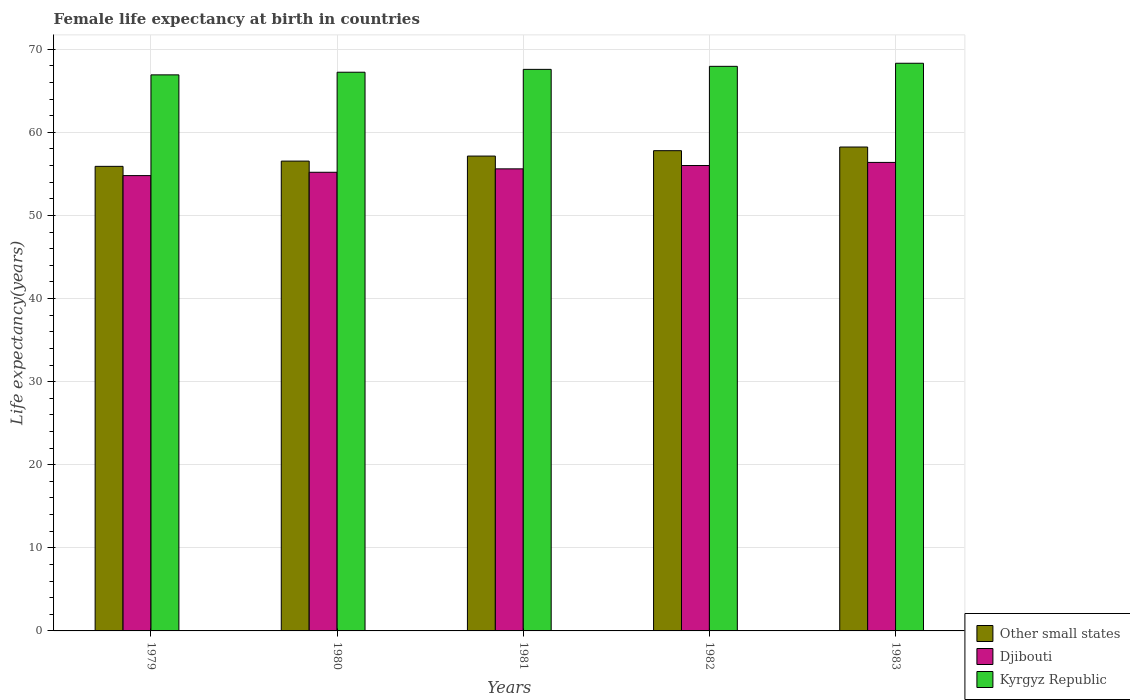How many groups of bars are there?
Your response must be concise. 5. Are the number of bars per tick equal to the number of legend labels?
Ensure brevity in your answer.  Yes. How many bars are there on the 4th tick from the right?
Make the answer very short. 3. What is the female life expectancy at birth in Other small states in 1979?
Your answer should be very brief. 55.91. Across all years, what is the maximum female life expectancy at birth in Other small states?
Your answer should be very brief. 58.24. Across all years, what is the minimum female life expectancy at birth in Djibouti?
Your answer should be very brief. 54.8. In which year was the female life expectancy at birth in Kyrgyz Republic maximum?
Make the answer very short. 1983. In which year was the female life expectancy at birth in Djibouti minimum?
Make the answer very short. 1979. What is the total female life expectancy at birth in Kyrgyz Republic in the graph?
Ensure brevity in your answer.  338.01. What is the difference between the female life expectancy at birth in Other small states in 1979 and that in 1980?
Make the answer very short. -0.63. What is the difference between the female life expectancy at birth in Djibouti in 1982 and the female life expectancy at birth in Kyrgyz Republic in 1983?
Make the answer very short. -12.31. What is the average female life expectancy at birth in Other small states per year?
Offer a very short reply. 57.13. In the year 1980, what is the difference between the female life expectancy at birth in Djibouti and female life expectancy at birth in Other small states?
Give a very brief answer. -1.34. What is the ratio of the female life expectancy at birth in Djibouti in 1982 to that in 1983?
Provide a short and direct response. 0.99. Is the female life expectancy at birth in Kyrgyz Republic in 1979 less than that in 1982?
Offer a terse response. Yes. Is the difference between the female life expectancy at birth in Djibouti in 1980 and 1983 greater than the difference between the female life expectancy at birth in Other small states in 1980 and 1983?
Your answer should be compact. Yes. What is the difference between the highest and the second highest female life expectancy at birth in Djibouti?
Provide a succinct answer. 0.38. What is the difference between the highest and the lowest female life expectancy at birth in Kyrgyz Republic?
Offer a terse response. 1.4. What does the 2nd bar from the left in 1982 represents?
Provide a short and direct response. Djibouti. What does the 3rd bar from the right in 1979 represents?
Your answer should be compact. Other small states. Is it the case that in every year, the sum of the female life expectancy at birth in Other small states and female life expectancy at birth in Djibouti is greater than the female life expectancy at birth in Kyrgyz Republic?
Make the answer very short. Yes. Are all the bars in the graph horizontal?
Give a very brief answer. No. How many years are there in the graph?
Keep it short and to the point. 5. Does the graph contain any zero values?
Provide a short and direct response. No. Does the graph contain grids?
Ensure brevity in your answer.  Yes. Where does the legend appear in the graph?
Provide a short and direct response. Bottom right. What is the title of the graph?
Provide a short and direct response. Female life expectancy at birth in countries. What is the label or title of the X-axis?
Provide a succinct answer. Years. What is the label or title of the Y-axis?
Your answer should be very brief. Life expectancy(years). What is the Life expectancy(years) of Other small states in 1979?
Give a very brief answer. 55.91. What is the Life expectancy(years) of Djibouti in 1979?
Make the answer very short. 54.8. What is the Life expectancy(years) in Kyrgyz Republic in 1979?
Give a very brief answer. 66.92. What is the Life expectancy(years) of Other small states in 1980?
Ensure brevity in your answer.  56.54. What is the Life expectancy(years) of Djibouti in 1980?
Keep it short and to the point. 55.2. What is the Life expectancy(years) of Kyrgyz Republic in 1980?
Keep it short and to the point. 67.24. What is the Life expectancy(years) in Other small states in 1981?
Provide a short and direct response. 57.15. What is the Life expectancy(years) in Djibouti in 1981?
Ensure brevity in your answer.  55.61. What is the Life expectancy(years) of Kyrgyz Republic in 1981?
Provide a short and direct response. 67.58. What is the Life expectancy(years) in Other small states in 1982?
Your answer should be compact. 57.8. What is the Life expectancy(years) in Djibouti in 1982?
Your response must be concise. 56.01. What is the Life expectancy(years) in Kyrgyz Republic in 1982?
Give a very brief answer. 67.95. What is the Life expectancy(years) of Other small states in 1983?
Make the answer very short. 58.24. What is the Life expectancy(years) of Djibouti in 1983?
Your answer should be very brief. 56.39. What is the Life expectancy(years) of Kyrgyz Republic in 1983?
Give a very brief answer. 68.32. Across all years, what is the maximum Life expectancy(years) in Other small states?
Your response must be concise. 58.24. Across all years, what is the maximum Life expectancy(years) in Djibouti?
Give a very brief answer. 56.39. Across all years, what is the maximum Life expectancy(years) in Kyrgyz Republic?
Give a very brief answer. 68.32. Across all years, what is the minimum Life expectancy(years) of Other small states?
Offer a terse response. 55.91. Across all years, what is the minimum Life expectancy(years) in Djibouti?
Give a very brief answer. 54.8. Across all years, what is the minimum Life expectancy(years) in Kyrgyz Republic?
Ensure brevity in your answer.  66.92. What is the total Life expectancy(years) of Other small states in the graph?
Your answer should be very brief. 285.64. What is the total Life expectancy(years) of Djibouti in the graph?
Your answer should be very brief. 278. What is the total Life expectancy(years) in Kyrgyz Republic in the graph?
Provide a short and direct response. 338.01. What is the difference between the Life expectancy(years) of Other small states in 1979 and that in 1980?
Keep it short and to the point. -0.63. What is the difference between the Life expectancy(years) of Djibouti in 1979 and that in 1980?
Ensure brevity in your answer.  -0.4. What is the difference between the Life expectancy(years) of Kyrgyz Republic in 1979 and that in 1980?
Provide a succinct answer. -0.32. What is the difference between the Life expectancy(years) of Other small states in 1979 and that in 1981?
Your answer should be very brief. -1.24. What is the difference between the Life expectancy(years) in Djibouti in 1979 and that in 1981?
Offer a very short reply. -0.81. What is the difference between the Life expectancy(years) of Kyrgyz Republic in 1979 and that in 1981?
Your answer should be compact. -0.66. What is the difference between the Life expectancy(years) of Other small states in 1979 and that in 1982?
Ensure brevity in your answer.  -1.89. What is the difference between the Life expectancy(years) of Djibouti in 1979 and that in 1982?
Ensure brevity in your answer.  -1.21. What is the difference between the Life expectancy(years) in Kyrgyz Republic in 1979 and that in 1982?
Keep it short and to the point. -1.03. What is the difference between the Life expectancy(years) of Other small states in 1979 and that in 1983?
Your response must be concise. -2.33. What is the difference between the Life expectancy(years) of Djibouti in 1979 and that in 1983?
Provide a succinct answer. -1.59. What is the difference between the Life expectancy(years) in Kyrgyz Republic in 1979 and that in 1983?
Provide a short and direct response. -1.4. What is the difference between the Life expectancy(years) of Other small states in 1980 and that in 1981?
Offer a terse response. -0.61. What is the difference between the Life expectancy(years) of Djibouti in 1980 and that in 1981?
Your answer should be compact. -0.41. What is the difference between the Life expectancy(years) of Kyrgyz Republic in 1980 and that in 1981?
Keep it short and to the point. -0.34. What is the difference between the Life expectancy(years) in Other small states in 1980 and that in 1982?
Your answer should be very brief. -1.25. What is the difference between the Life expectancy(years) of Djibouti in 1980 and that in 1982?
Offer a very short reply. -0.81. What is the difference between the Life expectancy(years) of Kyrgyz Republic in 1980 and that in 1982?
Provide a short and direct response. -0.71. What is the difference between the Life expectancy(years) in Other small states in 1980 and that in 1983?
Your response must be concise. -1.69. What is the difference between the Life expectancy(years) in Djibouti in 1980 and that in 1983?
Your response must be concise. -1.19. What is the difference between the Life expectancy(years) in Kyrgyz Republic in 1980 and that in 1983?
Your response must be concise. -1.08. What is the difference between the Life expectancy(years) in Other small states in 1981 and that in 1982?
Keep it short and to the point. -0.65. What is the difference between the Life expectancy(years) of Djibouti in 1981 and that in 1982?
Provide a short and direct response. -0.4. What is the difference between the Life expectancy(years) in Kyrgyz Republic in 1981 and that in 1982?
Offer a terse response. -0.36. What is the difference between the Life expectancy(years) in Other small states in 1981 and that in 1983?
Keep it short and to the point. -1.09. What is the difference between the Life expectancy(years) in Djibouti in 1981 and that in 1983?
Give a very brief answer. -0.78. What is the difference between the Life expectancy(years) of Kyrgyz Republic in 1981 and that in 1983?
Offer a very short reply. -0.73. What is the difference between the Life expectancy(years) of Other small states in 1982 and that in 1983?
Your response must be concise. -0.44. What is the difference between the Life expectancy(years) in Djibouti in 1982 and that in 1983?
Provide a succinct answer. -0.38. What is the difference between the Life expectancy(years) in Kyrgyz Republic in 1982 and that in 1983?
Make the answer very short. -0.37. What is the difference between the Life expectancy(years) in Other small states in 1979 and the Life expectancy(years) in Djibouti in 1980?
Ensure brevity in your answer.  0.71. What is the difference between the Life expectancy(years) of Other small states in 1979 and the Life expectancy(years) of Kyrgyz Republic in 1980?
Keep it short and to the point. -11.33. What is the difference between the Life expectancy(years) of Djibouti in 1979 and the Life expectancy(years) of Kyrgyz Republic in 1980?
Your answer should be very brief. -12.44. What is the difference between the Life expectancy(years) in Other small states in 1979 and the Life expectancy(years) in Djibouti in 1981?
Your answer should be compact. 0.3. What is the difference between the Life expectancy(years) of Other small states in 1979 and the Life expectancy(years) of Kyrgyz Republic in 1981?
Make the answer very short. -11.67. What is the difference between the Life expectancy(years) of Djibouti in 1979 and the Life expectancy(years) of Kyrgyz Republic in 1981?
Offer a terse response. -12.79. What is the difference between the Life expectancy(years) in Other small states in 1979 and the Life expectancy(years) in Djibouti in 1982?
Ensure brevity in your answer.  -0.1. What is the difference between the Life expectancy(years) in Other small states in 1979 and the Life expectancy(years) in Kyrgyz Republic in 1982?
Keep it short and to the point. -12.04. What is the difference between the Life expectancy(years) in Djibouti in 1979 and the Life expectancy(years) in Kyrgyz Republic in 1982?
Your response must be concise. -13.15. What is the difference between the Life expectancy(years) of Other small states in 1979 and the Life expectancy(years) of Djibouti in 1983?
Make the answer very short. -0.47. What is the difference between the Life expectancy(years) in Other small states in 1979 and the Life expectancy(years) in Kyrgyz Republic in 1983?
Make the answer very short. -12.41. What is the difference between the Life expectancy(years) of Djibouti in 1979 and the Life expectancy(years) of Kyrgyz Republic in 1983?
Your response must be concise. -13.52. What is the difference between the Life expectancy(years) of Other small states in 1980 and the Life expectancy(years) of Djibouti in 1981?
Provide a succinct answer. 0.93. What is the difference between the Life expectancy(years) in Other small states in 1980 and the Life expectancy(years) in Kyrgyz Republic in 1981?
Offer a terse response. -11.04. What is the difference between the Life expectancy(years) in Djibouti in 1980 and the Life expectancy(years) in Kyrgyz Republic in 1981?
Provide a succinct answer. -12.38. What is the difference between the Life expectancy(years) of Other small states in 1980 and the Life expectancy(years) of Djibouti in 1982?
Provide a short and direct response. 0.53. What is the difference between the Life expectancy(years) in Other small states in 1980 and the Life expectancy(years) in Kyrgyz Republic in 1982?
Your answer should be compact. -11.4. What is the difference between the Life expectancy(years) of Djibouti in 1980 and the Life expectancy(years) of Kyrgyz Republic in 1982?
Your answer should be compact. -12.75. What is the difference between the Life expectancy(years) of Other small states in 1980 and the Life expectancy(years) of Djibouti in 1983?
Keep it short and to the point. 0.16. What is the difference between the Life expectancy(years) of Other small states in 1980 and the Life expectancy(years) of Kyrgyz Republic in 1983?
Your response must be concise. -11.78. What is the difference between the Life expectancy(years) in Djibouti in 1980 and the Life expectancy(years) in Kyrgyz Republic in 1983?
Offer a very short reply. -13.12. What is the difference between the Life expectancy(years) of Other small states in 1981 and the Life expectancy(years) of Djibouti in 1982?
Your response must be concise. 1.14. What is the difference between the Life expectancy(years) in Other small states in 1981 and the Life expectancy(years) in Kyrgyz Republic in 1982?
Keep it short and to the point. -10.8. What is the difference between the Life expectancy(years) in Djibouti in 1981 and the Life expectancy(years) in Kyrgyz Republic in 1982?
Ensure brevity in your answer.  -12.34. What is the difference between the Life expectancy(years) of Other small states in 1981 and the Life expectancy(years) of Djibouti in 1983?
Ensure brevity in your answer.  0.76. What is the difference between the Life expectancy(years) in Other small states in 1981 and the Life expectancy(years) in Kyrgyz Republic in 1983?
Make the answer very short. -11.17. What is the difference between the Life expectancy(years) in Djibouti in 1981 and the Life expectancy(years) in Kyrgyz Republic in 1983?
Give a very brief answer. -12.71. What is the difference between the Life expectancy(years) of Other small states in 1982 and the Life expectancy(years) of Djibouti in 1983?
Make the answer very short. 1.41. What is the difference between the Life expectancy(years) in Other small states in 1982 and the Life expectancy(years) in Kyrgyz Republic in 1983?
Offer a terse response. -10.52. What is the difference between the Life expectancy(years) of Djibouti in 1982 and the Life expectancy(years) of Kyrgyz Republic in 1983?
Give a very brief answer. -12.31. What is the average Life expectancy(years) in Other small states per year?
Your answer should be very brief. 57.13. What is the average Life expectancy(years) of Djibouti per year?
Offer a very short reply. 55.6. What is the average Life expectancy(years) in Kyrgyz Republic per year?
Provide a succinct answer. 67.6. In the year 1979, what is the difference between the Life expectancy(years) of Other small states and Life expectancy(years) of Djibouti?
Your answer should be compact. 1.11. In the year 1979, what is the difference between the Life expectancy(years) of Other small states and Life expectancy(years) of Kyrgyz Republic?
Keep it short and to the point. -11.01. In the year 1979, what is the difference between the Life expectancy(years) in Djibouti and Life expectancy(years) in Kyrgyz Republic?
Provide a succinct answer. -12.12. In the year 1980, what is the difference between the Life expectancy(years) of Other small states and Life expectancy(years) of Djibouti?
Provide a short and direct response. 1.34. In the year 1980, what is the difference between the Life expectancy(years) in Other small states and Life expectancy(years) in Kyrgyz Republic?
Give a very brief answer. -10.7. In the year 1980, what is the difference between the Life expectancy(years) of Djibouti and Life expectancy(years) of Kyrgyz Republic?
Your answer should be very brief. -12.04. In the year 1981, what is the difference between the Life expectancy(years) of Other small states and Life expectancy(years) of Djibouti?
Provide a short and direct response. 1.54. In the year 1981, what is the difference between the Life expectancy(years) in Other small states and Life expectancy(years) in Kyrgyz Republic?
Keep it short and to the point. -10.43. In the year 1981, what is the difference between the Life expectancy(years) in Djibouti and Life expectancy(years) in Kyrgyz Republic?
Your answer should be very brief. -11.97. In the year 1982, what is the difference between the Life expectancy(years) of Other small states and Life expectancy(years) of Djibouti?
Offer a very short reply. 1.79. In the year 1982, what is the difference between the Life expectancy(years) in Other small states and Life expectancy(years) in Kyrgyz Republic?
Your answer should be very brief. -10.15. In the year 1982, what is the difference between the Life expectancy(years) in Djibouti and Life expectancy(years) in Kyrgyz Republic?
Your response must be concise. -11.94. In the year 1983, what is the difference between the Life expectancy(years) of Other small states and Life expectancy(years) of Djibouti?
Make the answer very short. 1.85. In the year 1983, what is the difference between the Life expectancy(years) of Other small states and Life expectancy(years) of Kyrgyz Republic?
Provide a succinct answer. -10.08. In the year 1983, what is the difference between the Life expectancy(years) of Djibouti and Life expectancy(years) of Kyrgyz Republic?
Provide a succinct answer. -11.93. What is the ratio of the Life expectancy(years) in Other small states in 1979 to that in 1980?
Provide a short and direct response. 0.99. What is the ratio of the Life expectancy(years) of Djibouti in 1979 to that in 1980?
Your response must be concise. 0.99. What is the ratio of the Life expectancy(years) in Kyrgyz Republic in 1979 to that in 1980?
Your answer should be compact. 1. What is the ratio of the Life expectancy(years) in Other small states in 1979 to that in 1981?
Offer a very short reply. 0.98. What is the ratio of the Life expectancy(years) in Djibouti in 1979 to that in 1981?
Keep it short and to the point. 0.99. What is the ratio of the Life expectancy(years) of Kyrgyz Republic in 1979 to that in 1981?
Offer a terse response. 0.99. What is the ratio of the Life expectancy(years) of Other small states in 1979 to that in 1982?
Give a very brief answer. 0.97. What is the ratio of the Life expectancy(years) in Djibouti in 1979 to that in 1982?
Provide a short and direct response. 0.98. What is the ratio of the Life expectancy(years) of Kyrgyz Republic in 1979 to that in 1982?
Provide a short and direct response. 0.98. What is the ratio of the Life expectancy(years) of Other small states in 1979 to that in 1983?
Provide a succinct answer. 0.96. What is the ratio of the Life expectancy(years) of Djibouti in 1979 to that in 1983?
Your answer should be compact. 0.97. What is the ratio of the Life expectancy(years) in Kyrgyz Republic in 1979 to that in 1983?
Offer a terse response. 0.98. What is the ratio of the Life expectancy(years) of Other small states in 1980 to that in 1981?
Your response must be concise. 0.99. What is the ratio of the Life expectancy(years) in Djibouti in 1980 to that in 1981?
Offer a terse response. 0.99. What is the ratio of the Life expectancy(years) in Other small states in 1980 to that in 1982?
Your answer should be compact. 0.98. What is the ratio of the Life expectancy(years) in Djibouti in 1980 to that in 1982?
Make the answer very short. 0.99. What is the ratio of the Life expectancy(years) of Other small states in 1980 to that in 1983?
Offer a terse response. 0.97. What is the ratio of the Life expectancy(years) in Djibouti in 1980 to that in 1983?
Provide a short and direct response. 0.98. What is the ratio of the Life expectancy(years) of Kyrgyz Republic in 1980 to that in 1983?
Your response must be concise. 0.98. What is the ratio of the Life expectancy(years) of Other small states in 1981 to that in 1982?
Ensure brevity in your answer.  0.99. What is the ratio of the Life expectancy(years) in Djibouti in 1981 to that in 1982?
Your answer should be very brief. 0.99. What is the ratio of the Life expectancy(years) in Kyrgyz Republic in 1981 to that in 1982?
Give a very brief answer. 0.99. What is the ratio of the Life expectancy(years) of Other small states in 1981 to that in 1983?
Give a very brief answer. 0.98. What is the ratio of the Life expectancy(years) in Djibouti in 1981 to that in 1983?
Keep it short and to the point. 0.99. What is the ratio of the Life expectancy(years) of Djibouti in 1982 to that in 1983?
Offer a terse response. 0.99. What is the ratio of the Life expectancy(years) of Kyrgyz Republic in 1982 to that in 1983?
Provide a succinct answer. 0.99. What is the difference between the highest and the second highest Life expectancy(years) in Other small states?
Offer a terse response. 0.44. What is the difference between the highest and the second highest Life expectancy(years) of Kyrgyz Republic?
Your response must be concise. 0.37. What is the difference between the highest and the lowest Life expectancy(years) in Other small states?
Keep it short and to the point. 2.33. What is the difference between the highest and the lowest Life expectancy(years) of Djibouti?
Your answer should be very brief. 1.59. What is the difference between the highest and the lowest Life expectancy(years) in Kyrgyz Republic?
Ensure brevity in your answer.  1.4. 